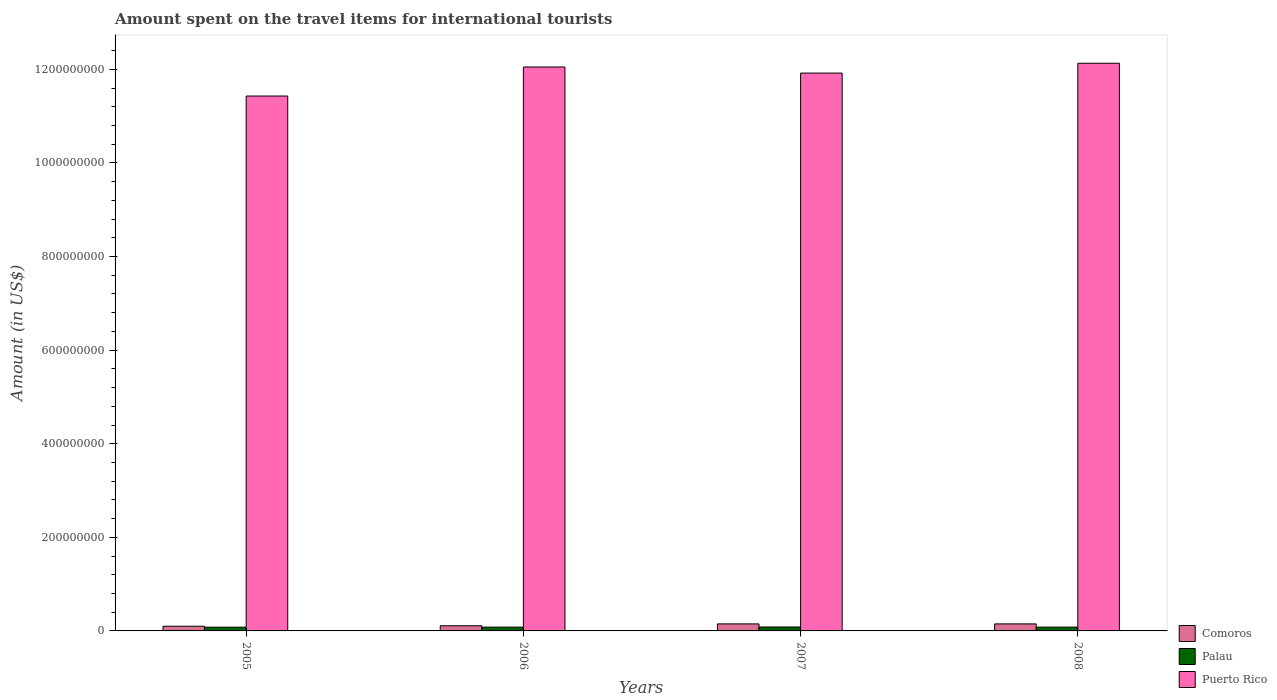How many different coloured bars are there?
Offer a terse response. 3. How many groups of bars are there?
Your answer should be very brief. 4. Are the number of bars on each tick of the X-axis equal?
Provide a succinct answer. Yes. How many bars are there on the 2nd tick from the left?
Provide a succinct answer. 3. How many bars are there on the 2nd tick from the right?
Offer a very short reply. 3. What is the amount spent on the travel items for international tourists in Puerto Rico in 2007?
Provide a short and direct response. 1.19e+09. Across all years, what is the maximum amount spent on the travel items for international tourists in Puerto Rico?
Your answer should be very brief. 1.21e+09. Across all years, what is the minimum amount spent on the travel items for international tourists in Puerto Rico?
Offer a very short reply. 1.14e+09. In which year was the amount spent on the travel items for international tourists in Comoros maximum?
Provide a succinct answer. 2007. What is the total amount spent on the travel items for international tourists in Comoros in the graph?
Offer a very short reply. 5.10e+07. What is the difference between the amount spent on the travel items for international tourists in Palau in 2005 and the amount spent on the travel items for international tourists in Puerto Rico in 2006?
Ensure brevity in your answer.  -1.20e+09. What is the average amount spent on the travel items for international tourists in Palau per year?
Make the answer very short. 8.15e+06. In the year 2008, what is the difference between the amount spent on the travel items for international tourists in Comoros and amount spent on the travel items for international tourists in Puerto Rico?
Offer a very short reply. -1.20e+09. In how many years, is the amount spent on the travel items for international tourists in Puerto Rico greater than 1120000000 US$?
Your answer should be compact. 4. What is the ratio of the amount spent on the travel items for international tourists in Comoros in 2005 to that in 2008?
Offer a very short reply. 0.67. Is the amount spent on the travel items for international tourists in Puerto Rico in 2006 less than that in 2008?
Give a very brief answer. Yes. What is the difference between the highest and the second highest amount spent on the travel items for international tourists in Palau?
Your response must be concise. 3.00e+05. What is the difference between the highest and the lowest amount spent on the travel items for international tourists in Puerto Rico?
Your answer should be very brief. 7.00e+07. What does the 3rd bar from the left in 2006 represents?
Keep it short and to the point. Puerto Rico. What does the 1st bar from the right in 2007 represents?
Offer a very short reply. Puerto Rico. What is the difference between two consecutive major ticks on the Y-axis?
Your response must be concise. 2.00e+08. Are the values on the major ticks of Y-axis written in scientific E-notation?
Offer a very short reply. No. Does the graph contain any zero values?
Your answer should be compact. No. Does the graph contain grids?
Provide a short and direct response. No. Where does the legend appear in the graph?
Provide a short and direct response. Bottom right. How many legend labels are there?
Keep it short and to the point. 3. What is the title of the graph?
Provide a short and direct response. Amount spent on the travel items for international tourists. Does "Finland" appear as one of the legend labels in the graph?
Offer a terse response. No. What is the label or title of the X-axis?
Ensure brevity in your answer.  Years. What is the Amount (in US$) in Comoros in 2005?
Your answer should be compact. 1.00e+07. What is the Amount (in US$) of Puerto Rico in 2005?
Offer a terse response. 1.14e+09. What is the Amount (in US$) in Comoros in 2006?
Offer a very short reply. 1.10e+07. What is the Amount (in US$) in Palau in 2006?
Your answer should be very brief. 8.10e+06. What is the Amount (in US$) in Puerto Rico in 2006?
Keep it short and to the point. 1.20e+09. What is the Amount (in US$) in Comoros in 2007?
Offer a terse response. 1.50e+07. What is the Amount (in US$) of Palau in 2007?
Keep it short and to the point. 8.40e+06. What is the Amount (in US$) of Puerto Rico in 2007?
Provide a short and direct response. 1.19e+09. What is the Amount (in US$) of Comoros in 2008?
Offer a terse response. 1.50e+07. What is the Amount (in US$) of Palau in 2008?
Keep it short and to the point. 8.10e+06. What is the Amount (in US$) in Puerto Rico in 2008?
Offer a very short reply. 1.21e+09. Across all years, what is the maximum Amount (in US$) of Comoros?
Provide a short and direct response. 1.50e+07. Across all years, what is the maximum Amount (in US$) in Palau?
Provide a succinct answer. 8.40e+06. Across all years, what is the maximum Amount (in US$) in Puerto Rico?
Your response must be concise. 1.21e+09. Across all years, what is the minimum Amount (in US$) of Comoros?
Your response must be concise. 1.00e+07. Across all years, what is the minimum Amount (in US$) in Palau?
Give a very brief answer. 8.00e+06. Across all years, what is the minimum Amount (in US$) of Puerto Rico?
Your answer should be compact. 1.14e+09. What is the total Amount (in US$) in Comoros in the graph?
Offer a very short reply. 5.10e+07. What is the total Amount (in US$) of Palau in the graph?
Your answer should be very brief. 3.26e+07. What is the total Amount (in US$) in Puerto Rico in the graph?
Give a very brief answer. 4.75e+09. What is the difference between the Amount (in US$) in Puerto Rico in 2005 and that in 2006?
Your answer should be very brief. -6.20e+07. What is the difference between the Amount (in US$) of Comoros in 2005 and that in 2007?
Offer a very short reply. -5.00e+06. What is the difference between the Amount (in US$) of Palau in 2005 and that in 2007?
Provide a succinct answer. -4.00e+05. What is the difference between the Amount (in US$) of Puerto Rico in 2005 and that in 2007?
Your answer should be very brief. -4.90e+07. What is the difference between the Amount (in US$) of Comoros in 2005 and that in 2008?
Provide a succinct answer. -5.00e+06. What is the difference between the Amount (in US$) in Palau in 2005 and that in 2008?
Ensure brevity in your answer.  -1.00e+05. What is the difference between the Amount (in US$) in Puerto Rico in 2005 and that in 2008?
Make the answer very short. -7.00e+07. What is the difference between the Amount (in US$) in Comoros in 2006 and that in 2007?
Offer a very short reply. -4.00e+06. What is the difference between the Amount (in US$) of Puerto Rico in 2006 and that in 2007?
Your answer should be compact. 1.30e+07. What is the difference between the Amount (in US$) of Puerto Rico in 2006 and that in 2008?
Ensure brevity in your answer.  -8.00e+06. What is the difference between the Amount (in US$) of Palau in 2007 and that in 2008?
Your response must be concise. 3.00e+05. What is the difference between the Amount (in US$) of Puerto Rico in 2007 and that in 2008?
Offer a very short reply. -2.10e+07. What is the difference between the Amount (in US$) of Comoros in 2005 and the Amount (in US$) of Palau in 2006?
Offer a very short reply. 1.90e+06. What is the difference between the Amount (in US$) in Comoros in 2005 and the Amount (in US$) in Puerto Rico in 2006?
Offer a terse response. -1.20e+09. What is the difference between the Amount (in US$) of Palau in 2005 and the Amount (in US$) of Puerto Rico in 2006?
Ensure brevity in your answer.  -1.20e+09. What is the difference between the Amount (in US$) in Comoros in 2005 and the Amount (in US$) in Palau in 2007?
Make the answer very short. 1.60e+06. What is the difference between the Amount (in US$) in Comoros in 2005 and the Amount (in US$) in Puerto Rico in 2007?
Keep it short and to the point. -1.18e+09. What is the difference between the Amount (in US$) in Palau in 2005 and the Amount (in US$) in Puerto Rico in 2007?
Your answer should be compact. -1.18e+09. What is the difference between the Amount (in US$) of Comoros in 2005 and the Amount (in US$) of Palau in 2008?
Your response must be concise. 1.90e+06. What is the difference between the Amount (in US$) of Comoros in 2005 and the Amount (in US$) of Puerto Rico in 2008?
Ensure brevity in your answer.  -1.20e+09. What is the difference between the Amount (in US$) of Palau in 2005 and the Amount (in US$) of Puerto Rico in 2008?
Provide a short and direct response. -1.20e+09. What is the difference between the Amount (in US$) of Comoros in 2006 and the Amount (in US$) of Palau in 2007?
Make the answer very short. 2.60e+06. What is the difference between the Amount (in US$) in Comoros in 2006 and the Amount (in US$) in Puerto Rico in 2007?
Your answer should be very brief. -1.18e+09. What is the difference between the Amount (in US$) of Palau in 2006 and the Amount (in US$) of Puerto Rico in 2007?
Offer a terse response. -1.18e+09. What is the difference between the Amount (in US$) in Comoros in 2006 and the Amount (in US$) in Palau in 2008?
Your response must be concise. 2.90e+06. What is the difference between the Amount (in US$) of Comoros in 2006 and the Amount (in US$) of Puerto Rico in 2008?
Offer a very short reply. -1.20e+09. What is the difference between the Amount (in US$) in Palau in 2006 and the Amount (in US$) in Puerto Rico in 2008?
Keep it short and to the point. -1.20e+09. What is the difference between the Amount (in US$) of Comoros in 2007 and the Amount (in US$) of Palau in 2008?
Ensure brevity in your answer.  6.90e+06. What is the difference between the Amount (in US$) of Comoros in 2007 and the Amount (in US$) of Puerto Rico in 2008?
Give a very brief answer. -1.20e+09. What is the difference between the Amount (in US$) in Palau in 2007 and the Amount (in US$) in Puerto Rico in 2008?
Your answer should be very brief. -1.20e+09. What is the average Amount (in US$) of Comoros per year?
Provide a short and direct response. 1.28e+07. What is the average Amount (in US$) of Palau per year?
Your answer should be very brief. 8.15e+06. What is the average Amount (in US$) in Puerto Rico per year?
Offer a very short reply. 1.19e+09. In the year 2005, what is the difference between the Amount (in US$) of Comoros and Amount (in US$) of Palau?
Offer a very short reply. 2.00e+06. In the year 2005, what is the difference between the Amount (in US$) in Comoros and Amount (in US$) in Puerto Rico?
Make the answer very short. -1.13e+09. In the year 2005, what is the difference between the Amount (in US$) in Palau and Amount (in US$) in Puerto Rico?
Ensure brevity in your answer.  -1.14e+09. In the year 2006, what is the difference between the Amount (in US$) of Comoros and Amount (in US$) of Palau?
Give a very brief answer. 2.90e+06. In the year 2006, what is the difference between the Amount (in US$) of Comoros and Amount (in US$) of Puerto Rico?
Your response must be concise. -1.19e+09. In the year 2006, what is the difference between the Amount (in US$) in Palau and Amount (in US$) in Puerto Rico?
Your response must be concise. -1.20e+09. In the year 2007, what is the difference between the Amount (in US$) of Comoros and Amount (in US$) of Palau?
Keep it short and to the point. 6.60e+06. In the year 2007, what is the difference between the Amount (in US$) of Comoros and Amount (in US$) of Puerto Rico?
Your answer should be very brief. -1.18e+09. In the year 2007, what is the difference between the Amount (in US$) in Palau and Amount (in US$) in Puerto Rico?
Ensure brevity in your answer.  -1.18e+09. In the year 2008, what is the difference between the Amount (in US$) in Comoros and Amount (in US$) in Palau?
Your answer should be compact. 6.90e+06. In the year 2008, what is the difference between the Amount (in US$) in Comoros and Amount (in US$) in Puerto Rico?
Your answer should be very brief. -1.20e+09. In the year 2008, what is the difference between the Amount (in US$) of Palau and Amount (in US$) of Puerto Rico?
Offer a very short reply. -1.20e+09. What is the ratio of the Amount (in US$) in Comoros in 2005 to that in 2006?
Give a very brief answer. 0.91. What is the ratio of the Amount (in US$) in Palau in 2005 to that in 2006?
Provide a short and direct response. 0.99. What is the ratio of the Amount (in US$) in Puerto Rico in 2005 to that in 2006?
Provide a succinct answer. 0.95. What is the ratio of the Amount (in US$) in Puerto Rico in 2005 to that in 2007?
Provide a short and direct response. 0.96. What is the ratio of the Amount (in US$) in Palau in 2005 to that in 2008?
Give a very brief answer. 0.99. What is the ratio of the Amount (in US$) in Puerto Rico in 2005 to that in 2008?
Offer a very short reply. 0.94. What is the ratio of the Amount (in US$) of Comoros in 2006 to that in 2007?
Your answer should be compact. 0.73. What is the ratio of the Amount (in US$) in Palau in 2006 to that in 2007?
Offer a terse response. 0.96. What is the ratio of the Amount (in US$) of Puerto Rico in 2006 to that in 2007?
Your response must be concise. 1.01. What is the ratio of the Amount (in US$) in Comoros in 2006 to that in 2008?
Your response must be concise. 0.73. What is the ratio of the Amount (in US$) in Palau in 2006 to that in 2008?
Provide a short and direct response. 1. What is the ratio of the Amount (in US$) of Puerto Rico in 2006 to that in 2008?
Offer a terse response. 0.99. What is the ratio of the Amount (in US$) of Comoros in 2007 to that in 2008?
Offer a very short reply. 1. What is the ratio of the Amount (in US$) in Puerto Rico in 2007 to that in 2008?
Provide a succinct answer. 0.98. What is the difference between the highest and the second highest Amount (in US$) in Palau?
Offer a terse response. 3.00e+05. What is the difference between the highest and the lowest Amount (in US$) in Puerto Rico?
Provide a succinct answer. 7.00e+07. 